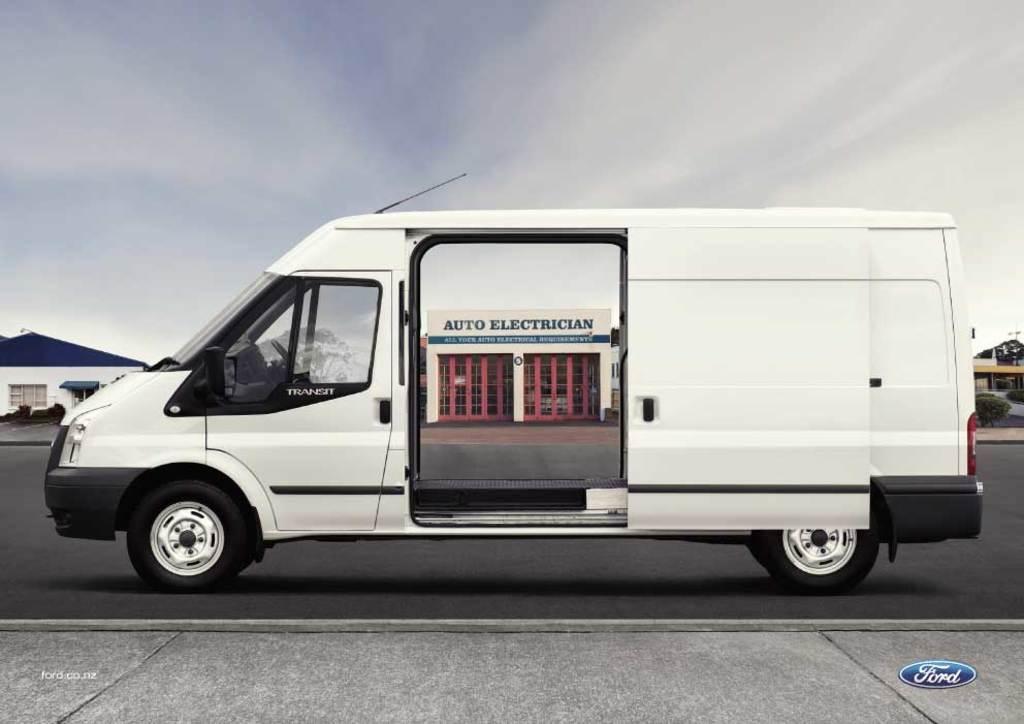What is the name of the building in the background?
Offer a terse response. Auto electrician. What type of vehicle is this?
Make the answer very short. Transit. 